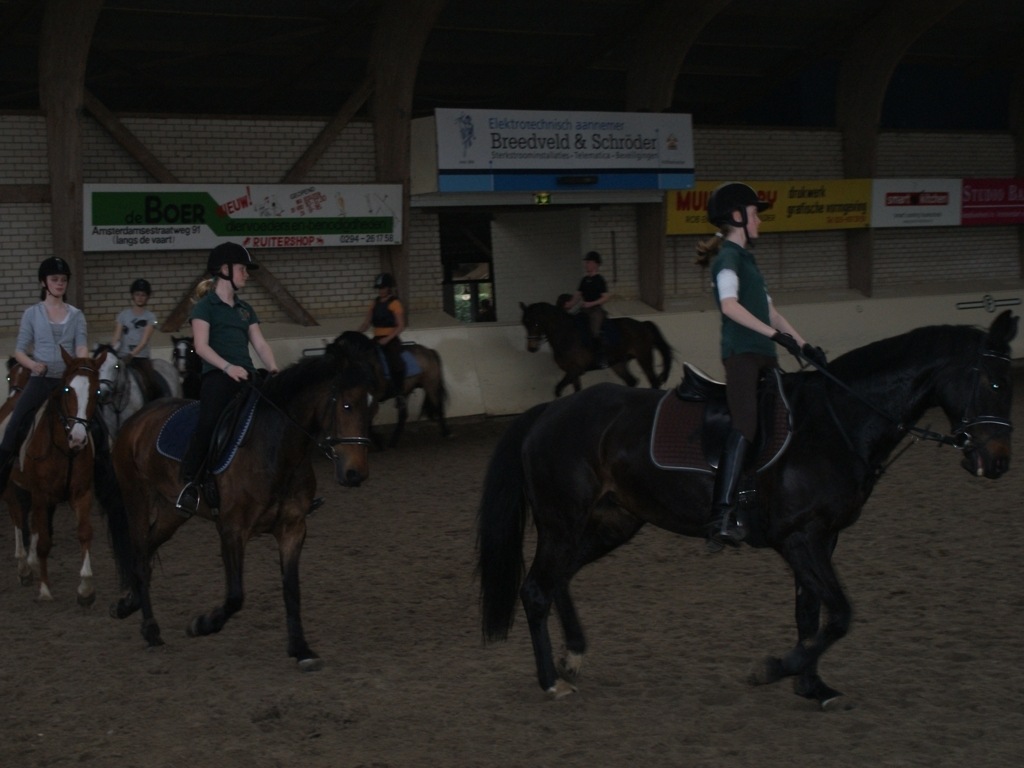Can you describe the horses' equipment? Each horse is equipped with a saddle, saddle pad, bridle, and reins. The riders are wearing helmets for safety. Are there any specific characteristics of the horses that stand out to you? The horses vary in color, from lighter browns to dark black, and show different physical builds, which may indicate a mix of breeds or ages. 